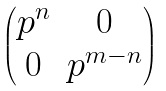Convert formula to latex. <formula><loc_0><loc_0><loc_500><loc_500>\begin{pmatrix} p ^ { n } & 0 \\ 0 & p ^ { m - n } \end{pmatrix}</formula> 